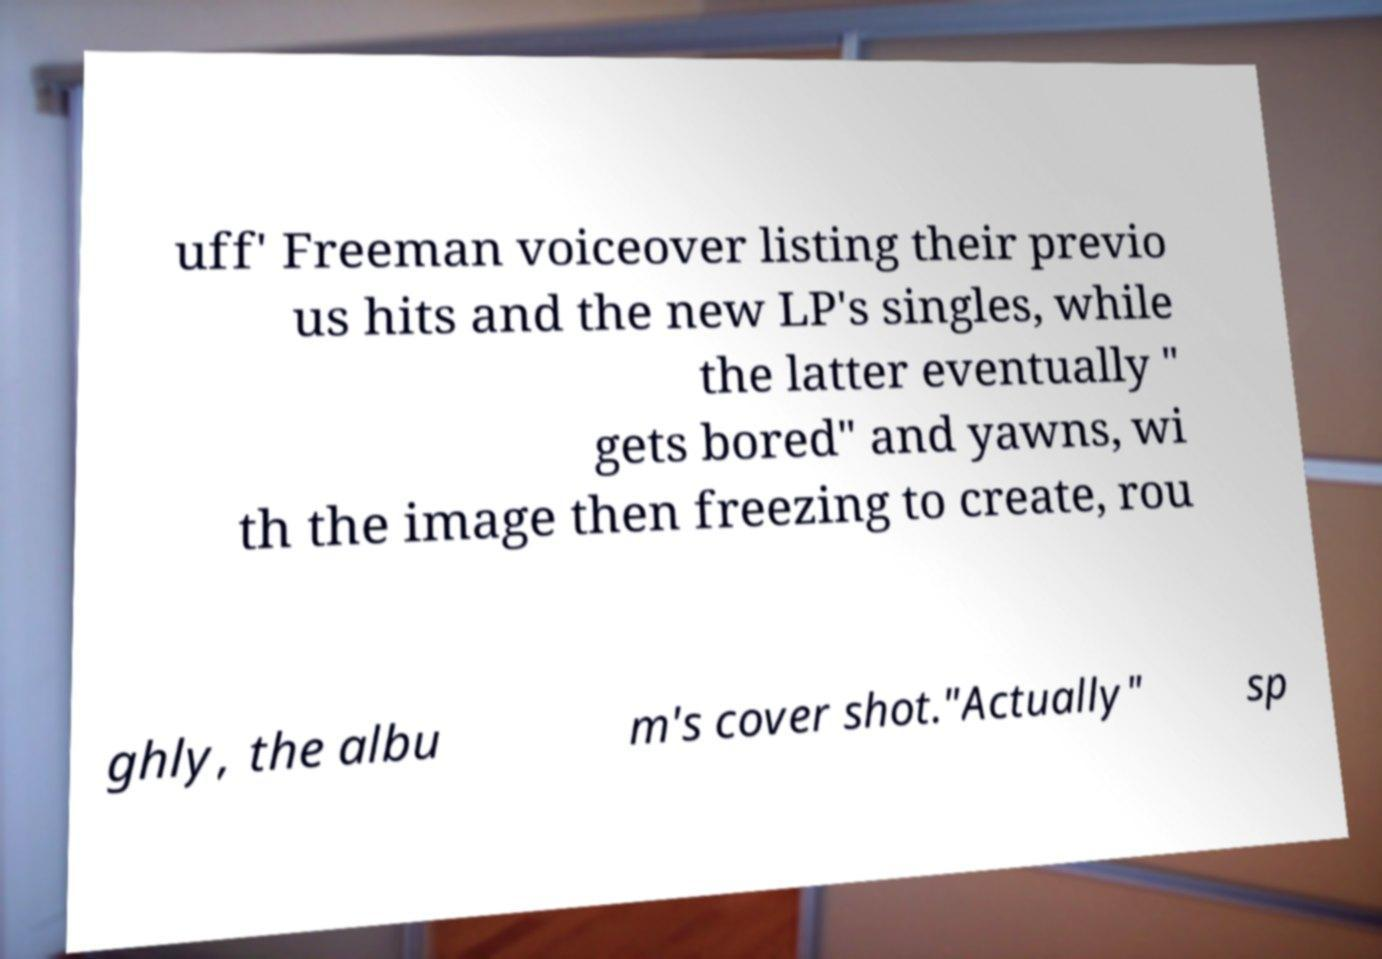Could you assist in decoding the text presented in this image and type it out clearly? uff' Freeman voiceover listing their previo us hits and the new LP's singles, while the latter eventually " gets bored" and yawns, wi th the image then freezing to create, rou ghly, the albu m's cover shot."Actually" sp 